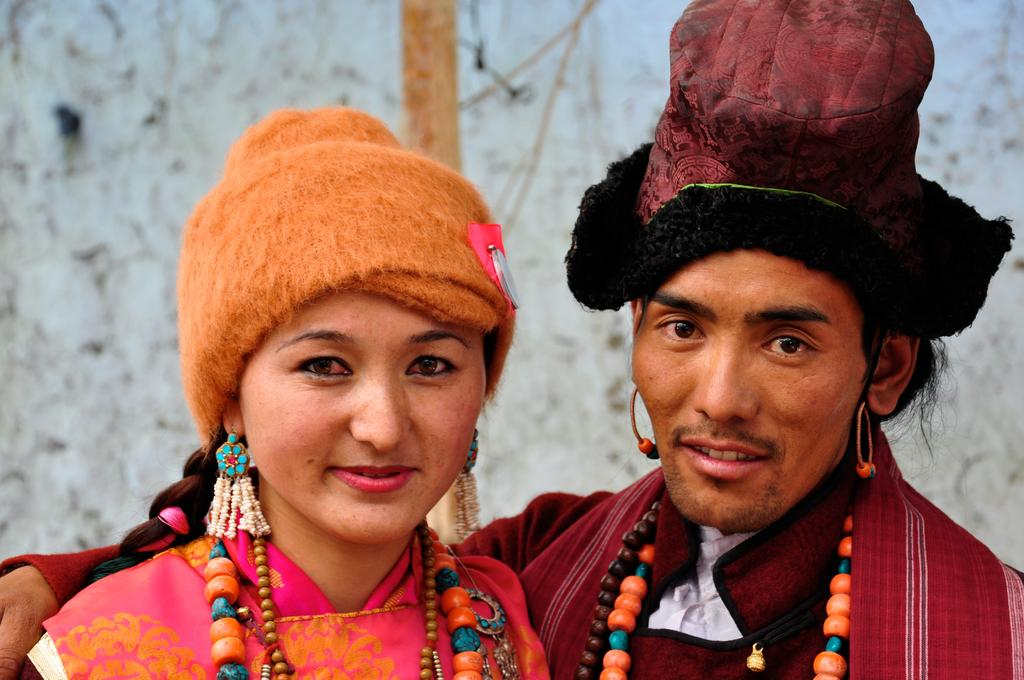Who are the people in the image? There is a woman and a man in the image. What are the expressions on their faces? Both the woman and the man are smiling. What is the man doing with the woman? The man is holding the woman. Can you describe the background of the image? The background of the image is blurry. How many horses can be seen running along the coast in the image? There are no horses or coast visible in the image; it features a woman and a man smiling and interacting with each other. 